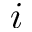Convert formula to latex. <formula><loc_0><loc_0><loc_500><loc_500>i</formula> 